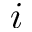Convert formula to latex. <formula><loc_0><loc_0><loc_500><loc_500>i</formula> 